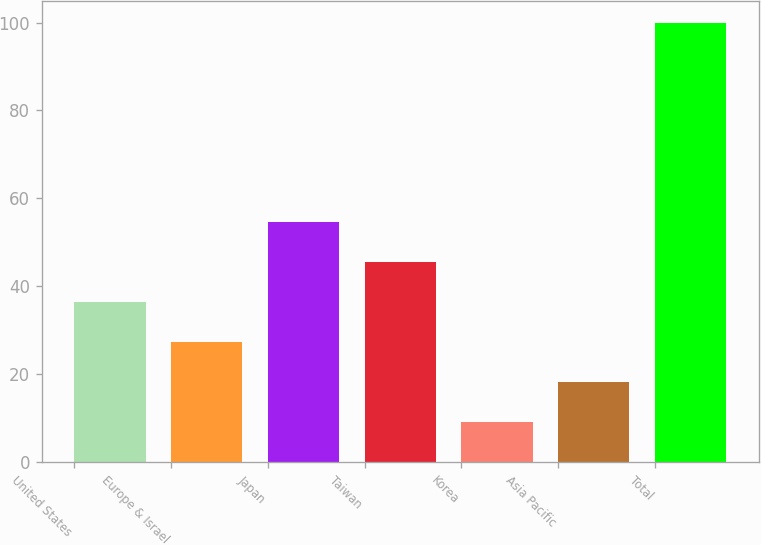<chart> <loc_0><loc_0><loc_500><loc_500><bar_chart><fcel>United States<fcel>Europe & Israel<fcel>Japan<fcel>Taiwan<fcel>Korea<fcel>Asia Pacific<fcel>Total<nl><fcel>36.3<fcel>27.2<fcel>54.5<fcel>45.4<fcel>9<fcel>18.1<fcel>100<nl></chart> 